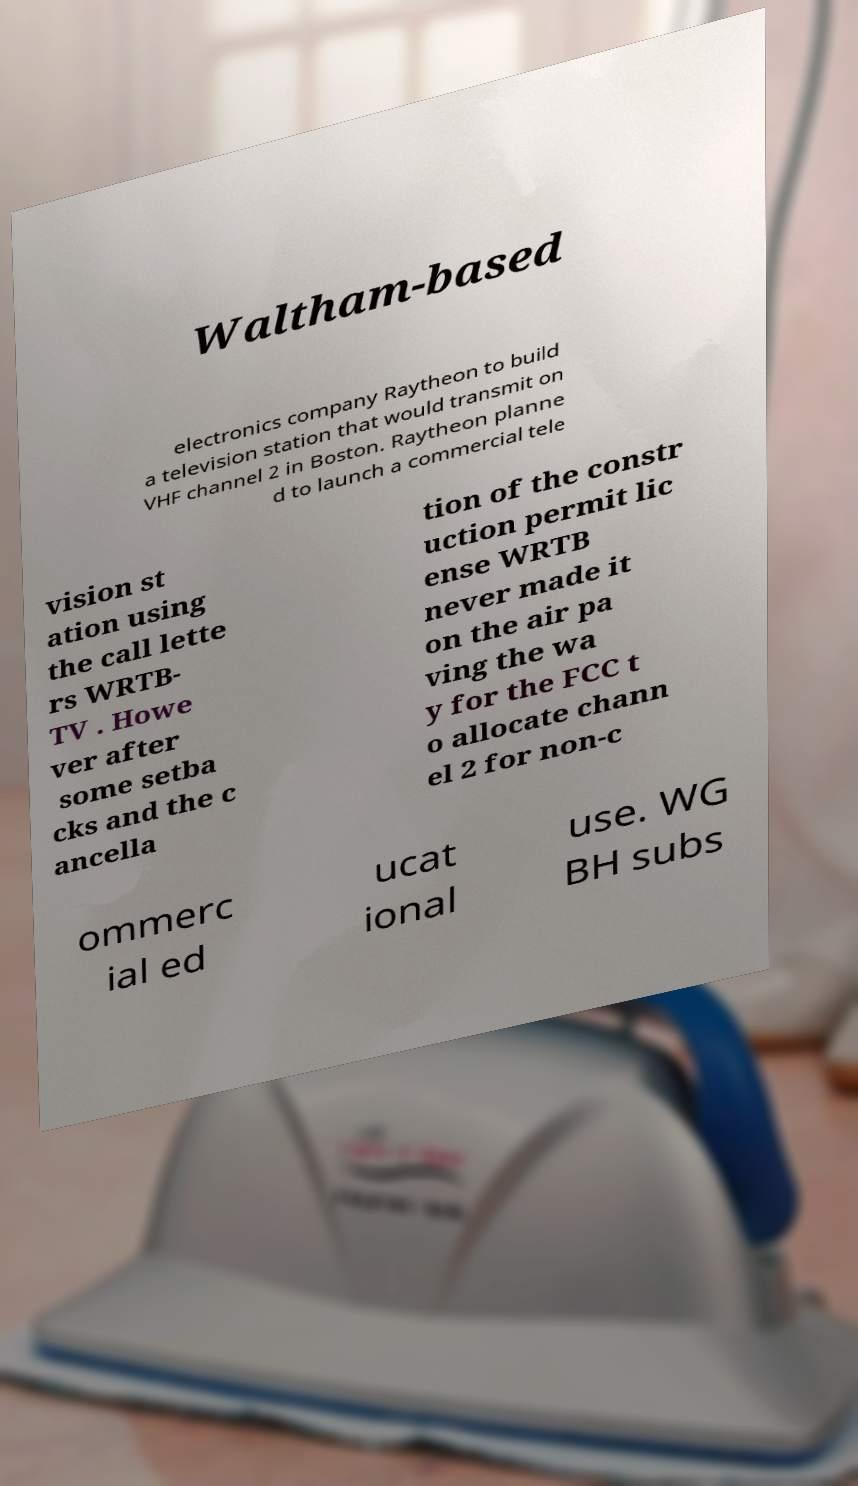Please identify and transcribe the text found in this image. Waltham-based electronics company Raytheon to build a television station that would transmit on VHF channel 2 in Boston. Raytheon planne d to launch a commercial tele vision st ation using the call lette rs WRTB- TV . Howe ver after some setba cks and the c ancella tion of the constr uction permit lic ense WRTB never made it on the air pa ving the wa y for the FCC t o allocate chann el 2 for non-c ommerc ial ed ucat ional use. WG BH subs 